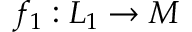Convert formula to latex. <formula><loc_0><loc_0><loc_500><loc_500>f _ { 1 } \colon L _ { 1 } \to M</formula> 